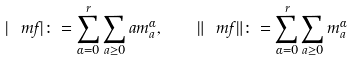<formula> <loc_0><loc_0><loc_500><loc_500>| \ m f | \colon = \sum _ { \alpha = 0 } ^ { r } \sum _ { a \geq 0 } a m _ { a } ^ { \alpha } , \quad \| \ m f \| \colon = \sum _ { \alpha = 0 } ^ { r } \sum _ { a \geq 0 } m _ { a } ^ { \alpha }</formula> 